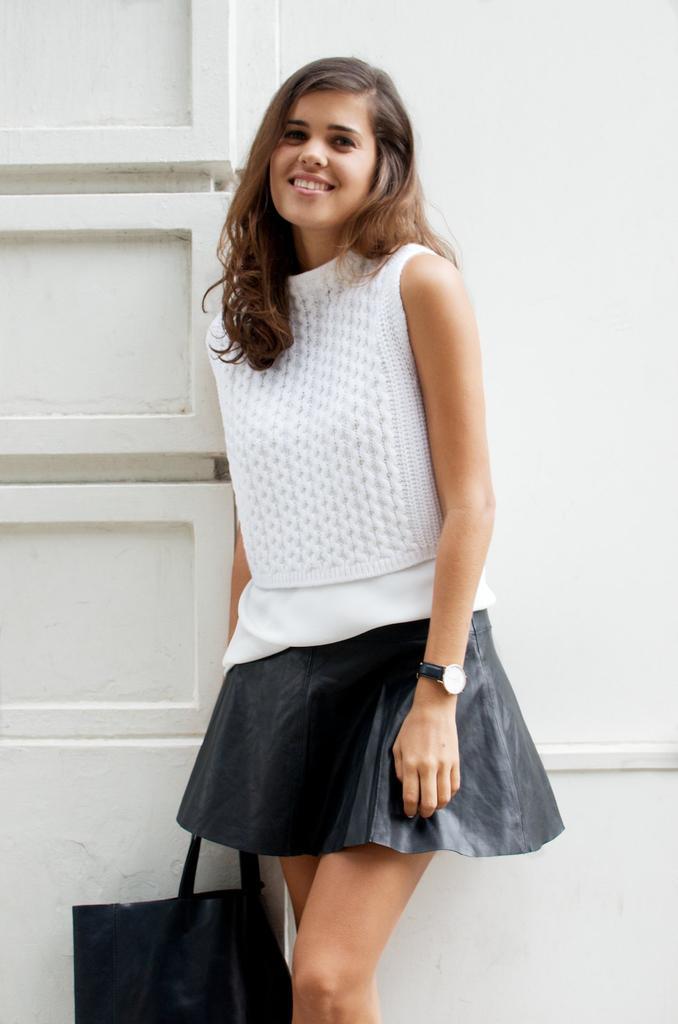Please provide a concise description of this image. This picture shows a woman standing with a smile on her face and she holds a bag in her hand 